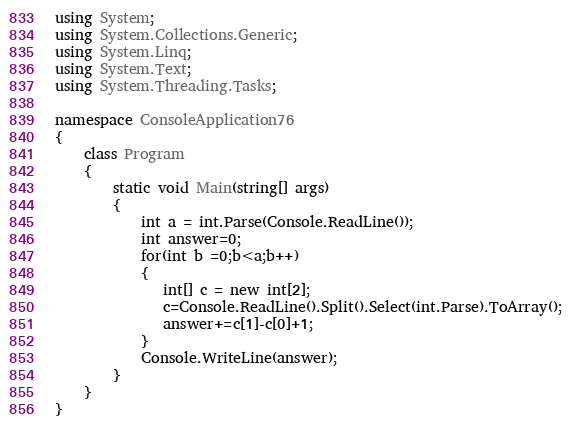Convert code to text. <code><loc_0><loc_0><loc_500><loc_500><_C#_>using System;
using System.Collections.Generic;
using System.Linq;
using System.Text;
using System.Threading.Tasks;
 
namespace ConsoleApplication76
{
    class Program
    {
        static void Main(string[] args)
        {
            int a = int.Parse(Console.ReadLine());
            int answer=0;
            for(int b =0;b<a;b++)
            {
               int[] c = new int[2];
               c=Console.ReadLine().Split().Select(int.Parse).ToArray();
               answer+=c[1]-c[0]+1;
            }
            Console.WriteLine(answer);
        }
    }
}
</code> 